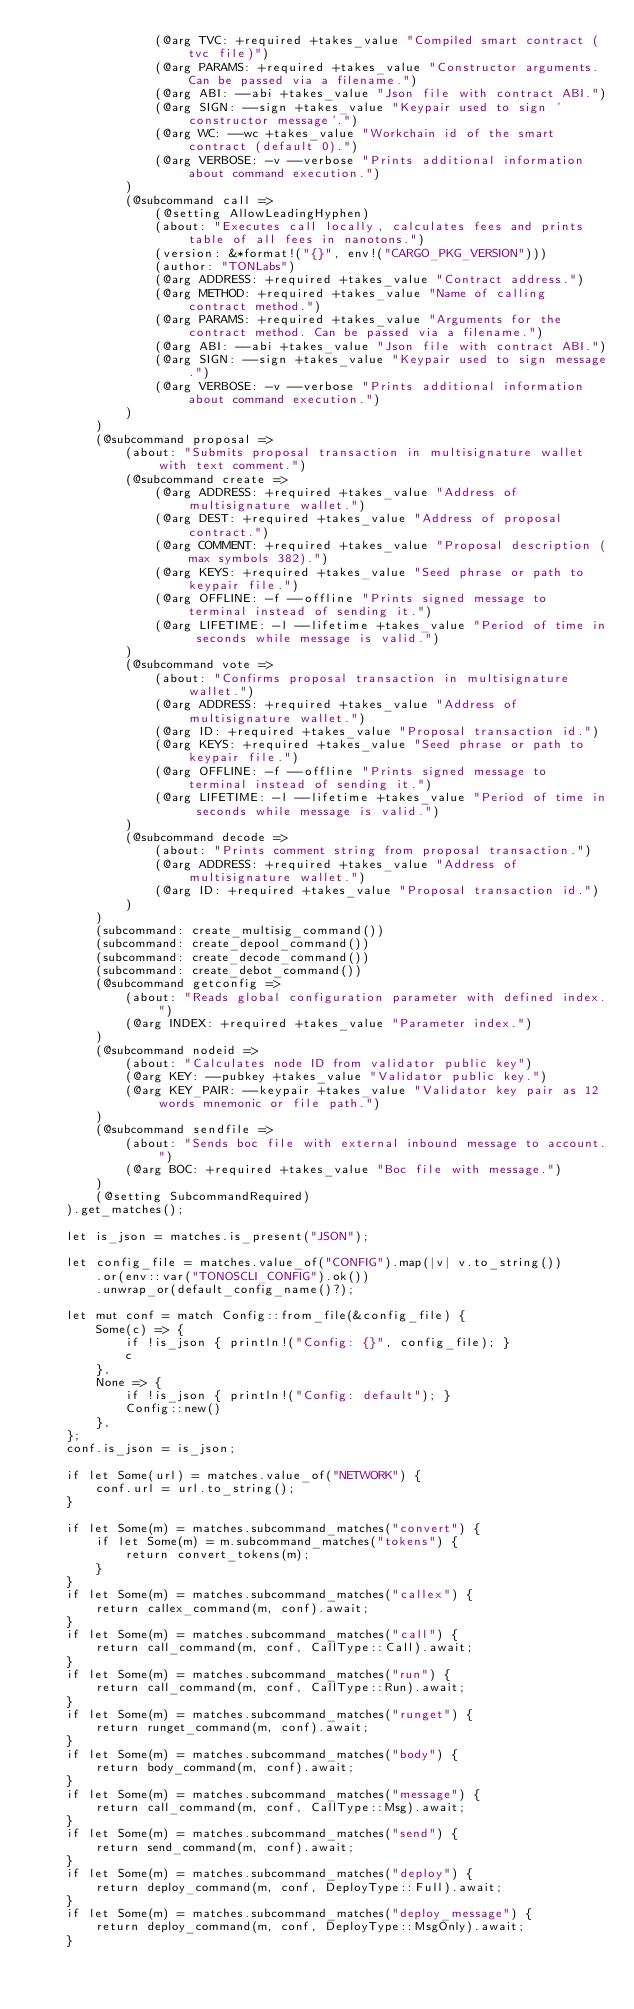<code> <loc_0><loc_0><loc_500><loc_500><_Rust_>                (@arg TVC: +required +takes_value "Compiled smart contract (tvc file)")
                (@arg PARAMS: +required +takes_value "Constructor arguments. Can be passed via a filename.")
                (@arg ABI: --abi +takes_value "Json file with contract ABI.")
                (@arg SIGN: --sign +takes_value "Keypair used to sign 'constructor message'.")
                (@arg WC: --wc +takes_value "Workchain id of the smart contract (default 0).")
                (@arg VERBOSE: -v --verbose "Prints additional information about command execution.")
            )
            (@subcommand call =>
                (@setting AllowLeadingHyphen)
                (about: "Executes call locally, calculates fees and prints table of all fees in nanotons.")
                (version: &*format!("{}", env!("CARGO_PKG_VERSION")))
                (author: "TONLabs")
                (@arg ADDRESS: +required +takes_value "Contract address.")
                (@arg METHOD: +required +takes_value "Name of calling contract method.")
                (@arg PARAMS: +required +takes_value "Arguments for the contract method. Can be passed via a filename.")
                (@arg ABI: --abi +takes_value "Json file with contract ABI.")
                (@arg SIGN: --sign +takes_value "Keypair used to sign message.")
                (@arg VERBOSE: -v --verbose "Prints additional information about command execution.")
            )
        )
        (@subcommand proposal =>
            (about: "Submits proposal transaction in multisignature wallet with text comment.")
            (@subcommand create =>
                (@arg ADDRESS: +required +takes_value "Address of multisignature wallet.")
                (@arg DEST: +required +takes_value "Address of proposal contract.")
                (@arg COMMENT: +required +takes_value "Proposal description (max symbols 382).")
                (@arg KEYS: +required +takes_value "Seed phrase or path to keypair file.")
                (@arg OFFLINE: -f --offline "Prints signed message to terminal instead of sending it.")
                (@arg LIFETIME: -l --lifetime +takes_value "Period of time in seconds while message is valid.")
            )
            (@subcommand vote =>
                (about: "Confirms proposal transaction in multisignature wallet.")
                (@arg ADDRESS: +required +takes_value "Address of multisignature wallet.")
                (@arg ID: +required +takes_value "Proposal transaction id.")
                (@arg KEYS: +required +takes_value "Seed phrase or path to keypair file.")
                (@arg OFFLINE: -f --offline "Prints signed message to terminal instead of sending it.")
                (@arg LIFETIME: -l --lifetime +takes_value "Period of time in seconds while message is valid.")
            )
            (@subcommand decode =>
                (about: "Prints comment string from proposal transaction.")
                (@arg ADDRESS: +required +takes_value "Address of multisignature wallet.")
                (@arg ID: +required +takes_value "Proposal transaction id.")
            )
        )
        (subcommand: create_multisig_command())
        (subcommand: create_depool_command())
        (subcommand: create_decode_command())
        (subcommand: create_debot_command())
        (@subcommand getconfig =>
            (about: "Reads global configuration parameter with defined index.")
            (@arg INDEX: +required +takes_value "Parameter index.")
        )
        (@subcommand nodeid =>
            (about: "Calculates node ID from validator public key")
            (@arg KEY: --pubkey +takes_value "Validator public key.")
            (@arg KEY_PAIR: --keypair +takes_value "Validator key pair as 12 words mnemonic or file path.")
        )
        (@subcommand sendfile =>
            (about: "Sends boc file with external inbound message to account.")
            (@arg BOC: +required +takes_value "Boc file with message.")
        )
        (@setting SubcommandRequired)
    ).get_matches();

    let is_json = matches.is_present("JSON");

    let config_file = matches.value_of("CONFIG").map(|v| v.to_string())
        .or(env::var("TONOSCLI_CONFIG").ok())
        .unwrap_or(default_config_name()?);

    let mut conf = match Config::from_file(&config_file) {
        Some(c) => {
            if !is_json { println!("Config: {}", config_file); }
            c
        },
        None => {
            if !is_json { println!("Config: default"); }
            Config::new()
        },
    };
    conf.is_json = is_json;

    if let Some(url) = matches.value_of("NETWORK") {
        conf.url = url.to_string();
    }

    if let Some(m) = matches.subcommand_matches("convert") {
        if let Some(m) = m.subcommand_matches("tokens") {
            return convert_tokens(m);
        }
    }
    if let Some(m) = matches.subcommand_matches("callex") {
        return callex_command(m, conf).await;
    }
    if let Some(m) = matches.subcommand_matches("call") {
        return call_command(m, conf, CallType::Call).await;
    }
    if let Some(m) = matches.subcommand_matches("run") {
        return call_command(m, conf, CallType::Run).await;
    }
    if let Some(m) = matches.subcommand_matches("runget") {
        return runget_command(m, conf).await;
    }
    if let Some(m) = matches.subcommand_matches("body") {
        return body_command(m, conf).await;
    }
    if let Some(m) = matches.subcommand_matches("message") {
        return call_command(m, conf, CallType::Msg).await;
    }
    if let Some(m) = matches.subcommand_matches("send") {
        return send_command(m, conf).await;
    }
    if let Some(m) = matches.subcommand_matches("deploy") {
        return deploy_command(m, conf, DeployType::Full).await;
    }
    if let Some(m) = matches.subcommand_matches("deploy_message") {
        return deploy_command(m, conf, DeployType::MsgOnly).await;
    }</code> 